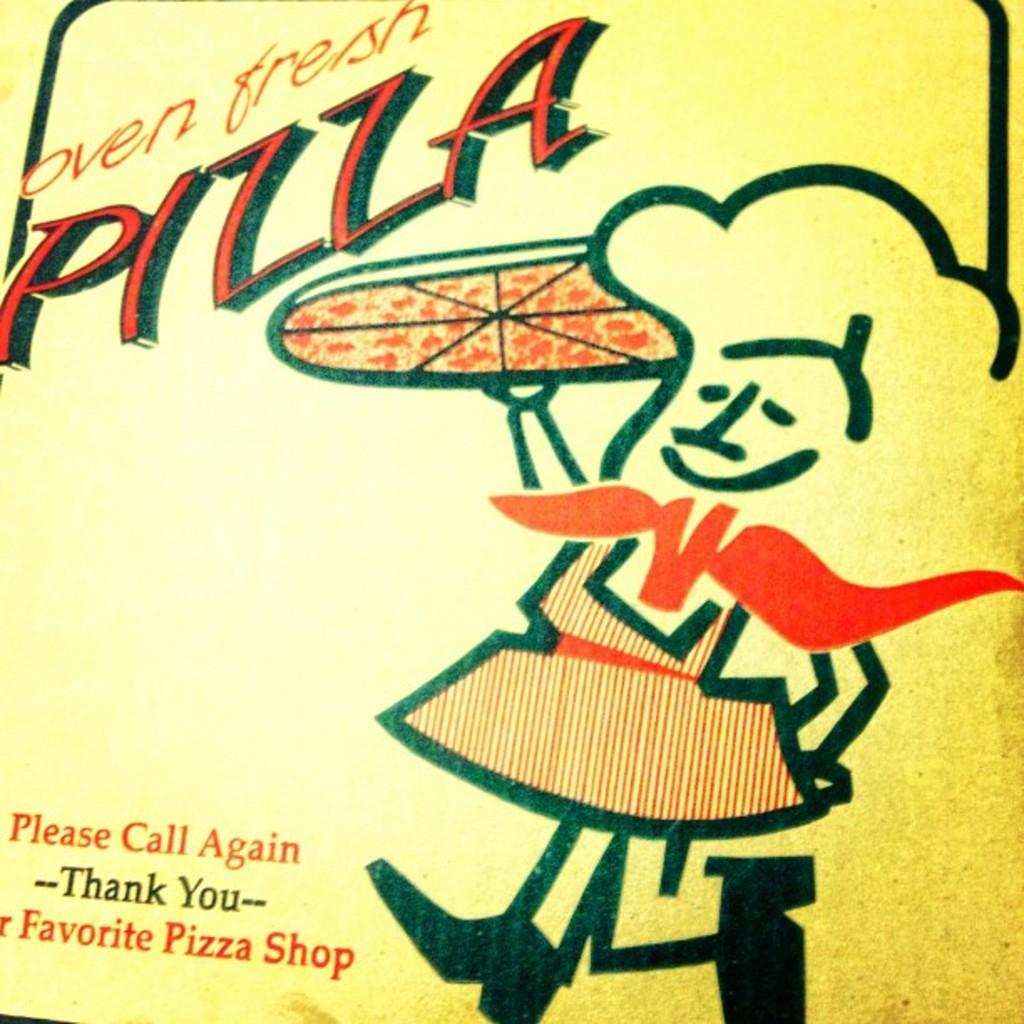<image>
Share a concise interpretation of the image provided. the logo for an oven fresh pizza shop with a man illustrated carrying a pizza. 